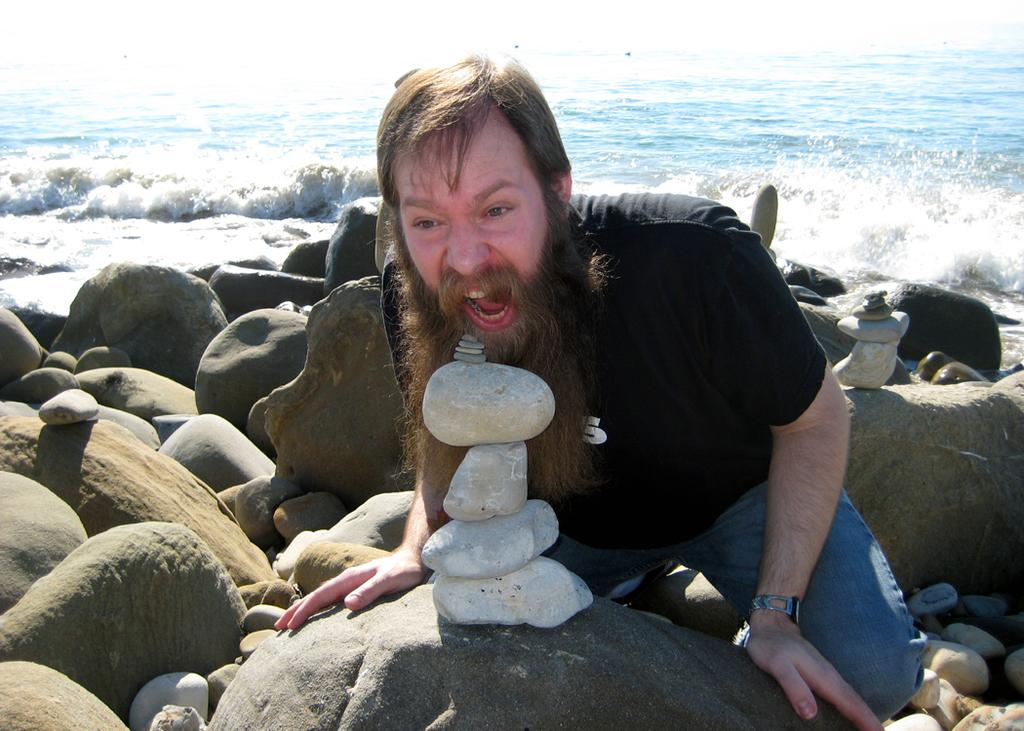What is present in the image? There is a man in the image. What type of natural elements can be seen in the image? There are rocks in the image. What can be seen in the background of the image? There is water visible in the background of the image. What type of flower is growing near the man in the image? There is no flower present in the image. Is there a lamp visible in the image? There is no lamp present in the image. 